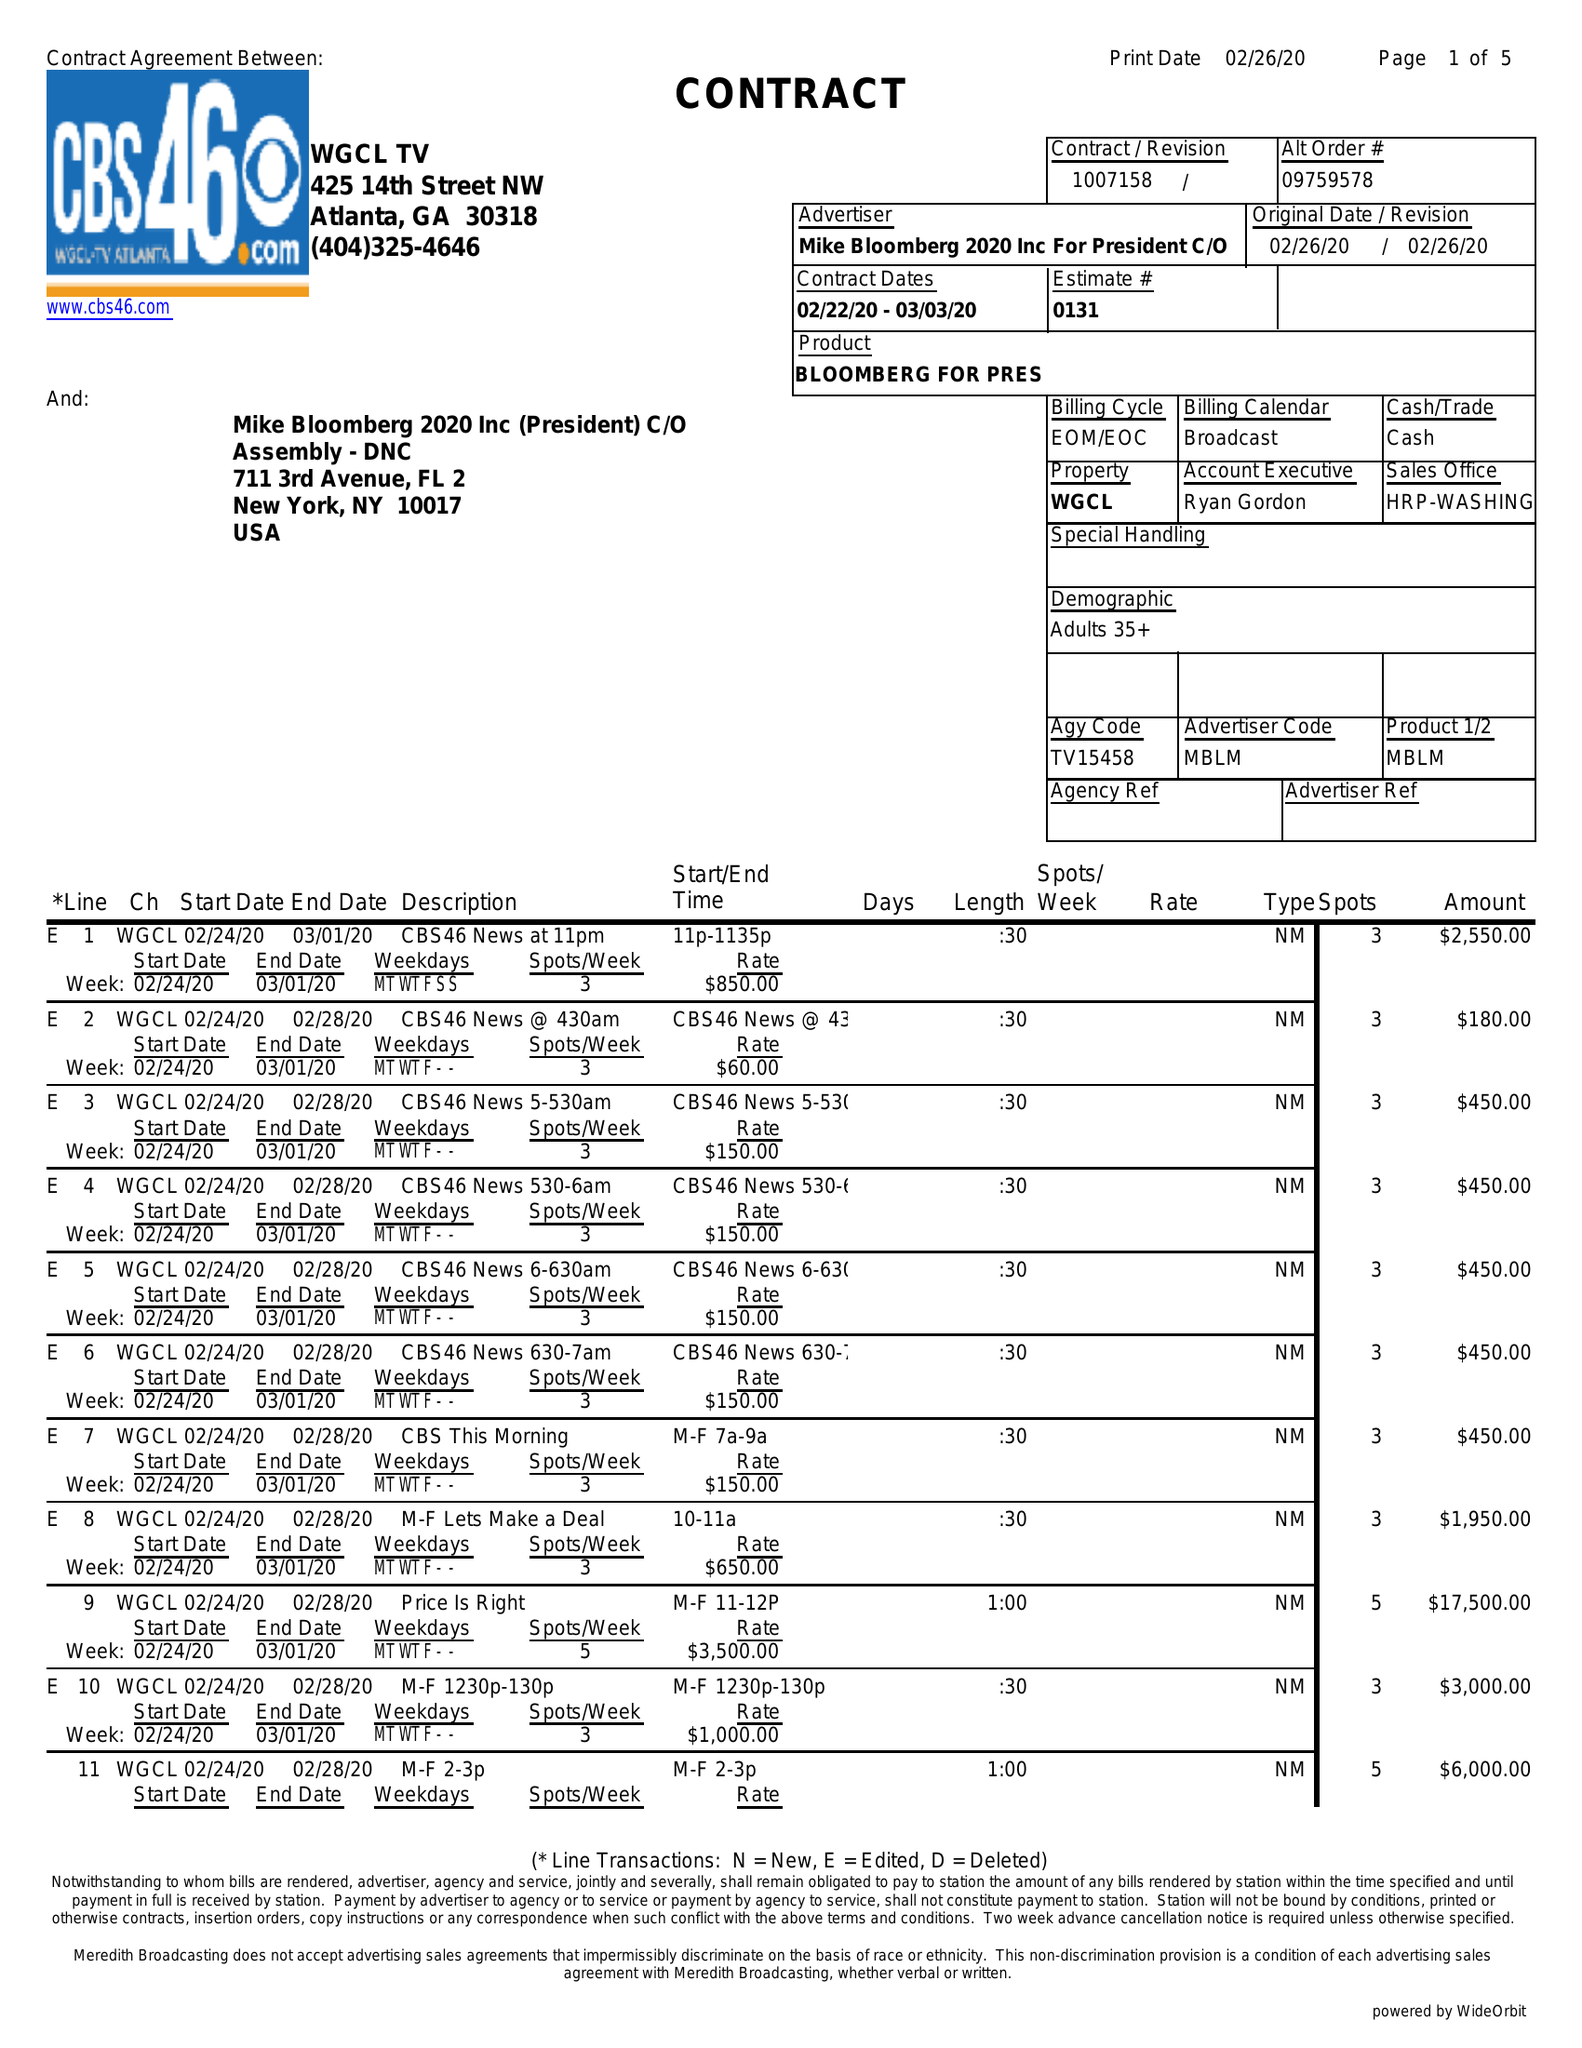What is the value for the flight_to?
Answer the question using a single word or phrase. 03/03/20 